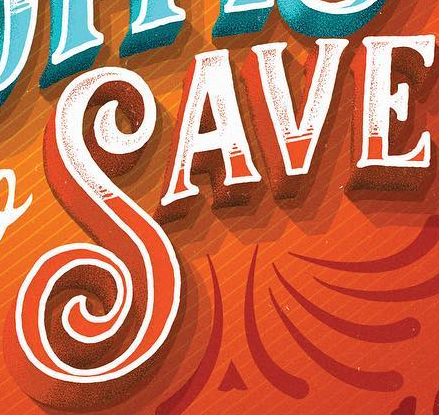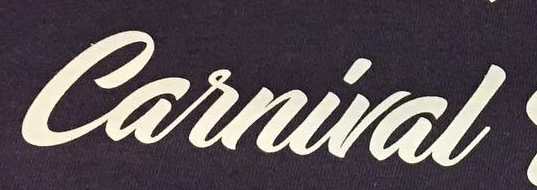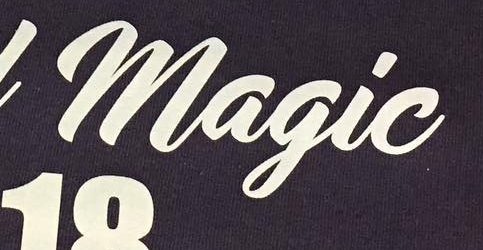Read the text from these images in sequence, separated by a semicolon. SAVE; Carnival; Magic 